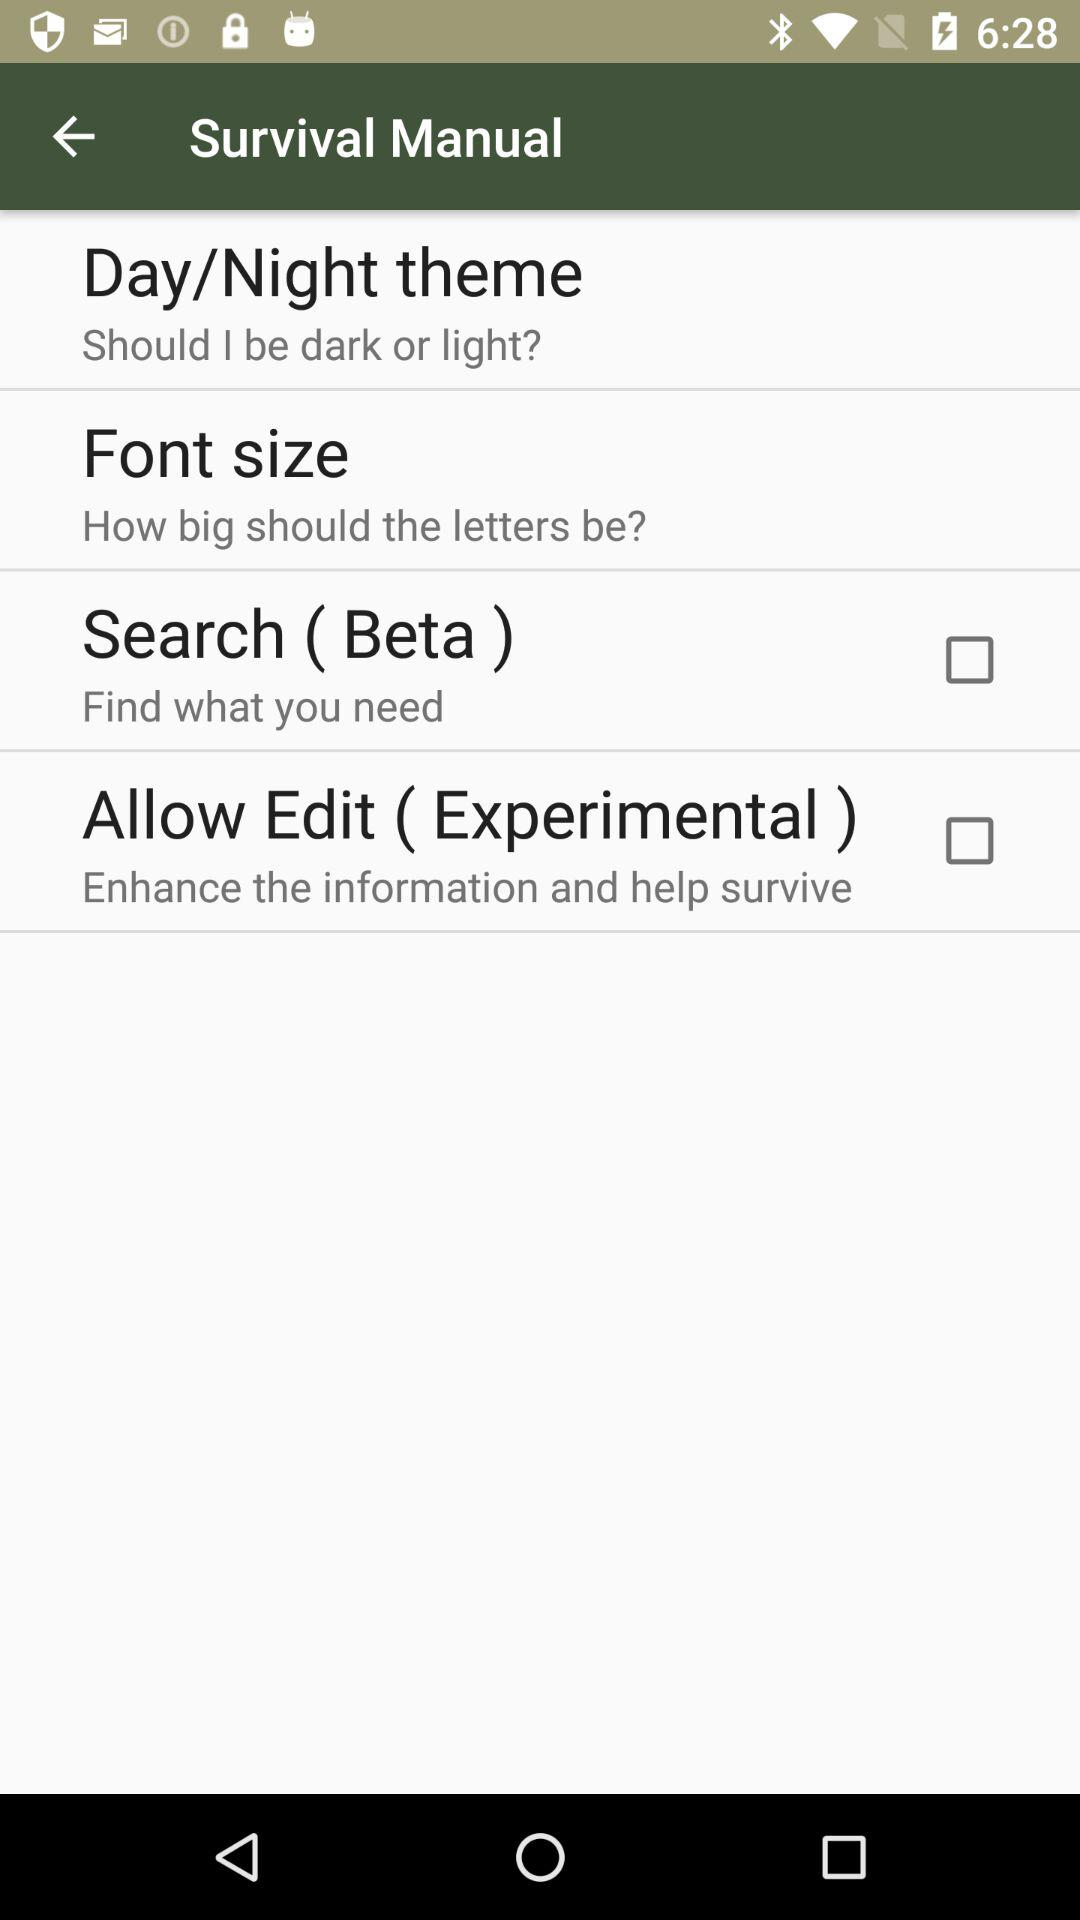What's the status of "Search ( Beta )"? The status of "Search ( Beta )" is "off". 